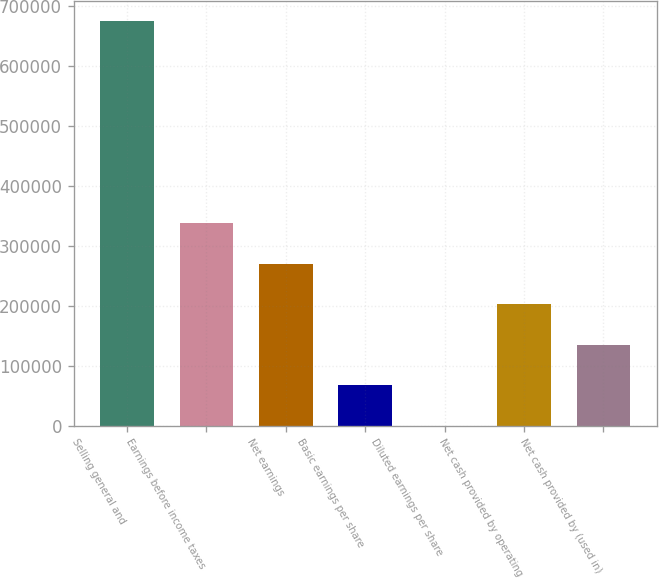Convert chart. <chart><loc_0><loc_0><loc_500><loc_500><bar_chart><fcel>Selling general and<fcel>Earnings before income taxes<fcel>Net earnings<fcel>Basic earnings per share<fcel>Diluted earnings per share<fcel>Net cash provided by operating<fcel>Net cash provided by (used in)<nl><fcel>674370<fcel>337185<fcel>269748<fcel>67437.6<fcel>0.63<fcel>202311<fcel>134875<nl></chart> 